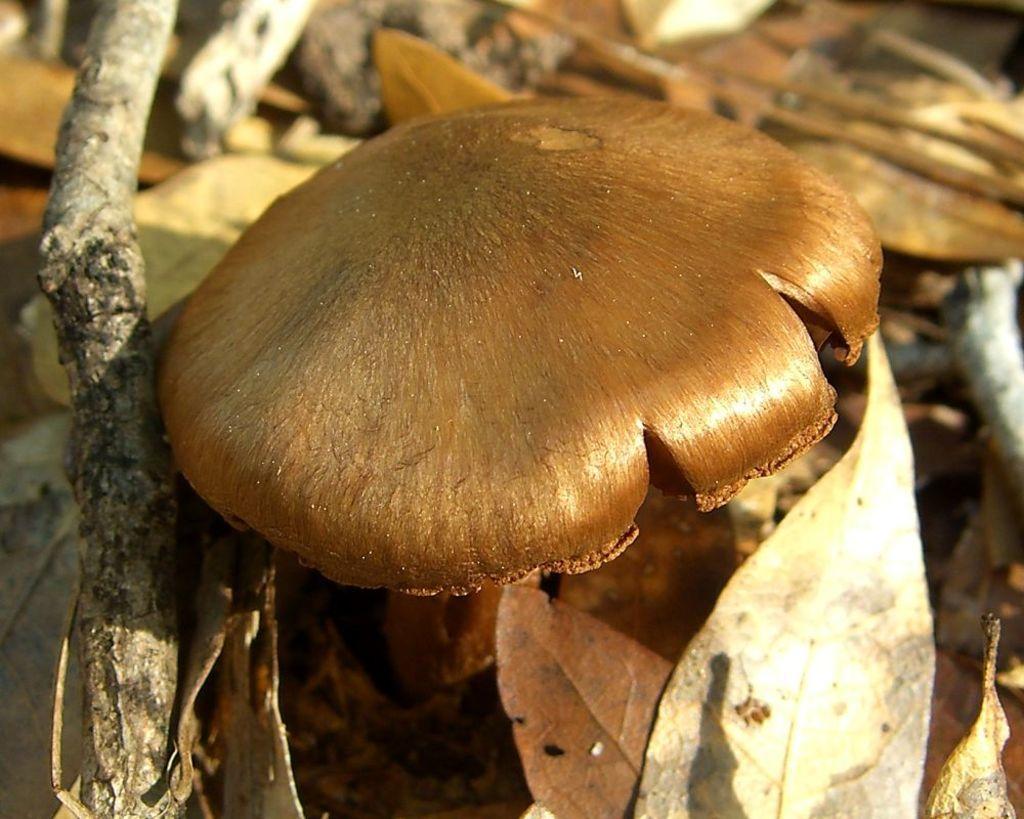Describe this image in one or two sentences. In this image we can see a mushroom and dried leaves. Background it is blur. 